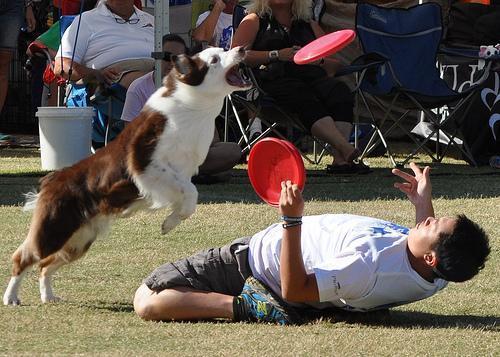How many frisbees are shown?
Give a very brief answer. 2. 